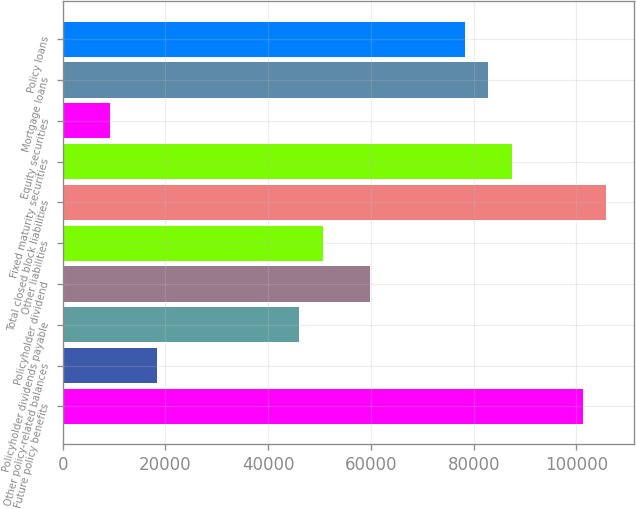Convert chart to OTSL. <chart><loc_0><loc_0><loc_500><loc_500><bar_chart><fcel>Future policy benefits<fcel>Other policy-related balances<fcel>Policyholder dividends payable<fcel>Policyholder dividend<fcel>Other liabilities<fcel>Total closed block liabilities<fcel>Fixed maturity securities<fcel>Equity securities<fcel>Mortgage loans<fcel>Policy loans<nl><fcel>101258<fcel>18418.8<fcel>46032<fcel>59838.6<fcel>50634.2<fcel>105861<fcel>87451.8<fcel>9214.4<fcel>82849.6<fcel>78247.4<nl></chart> 